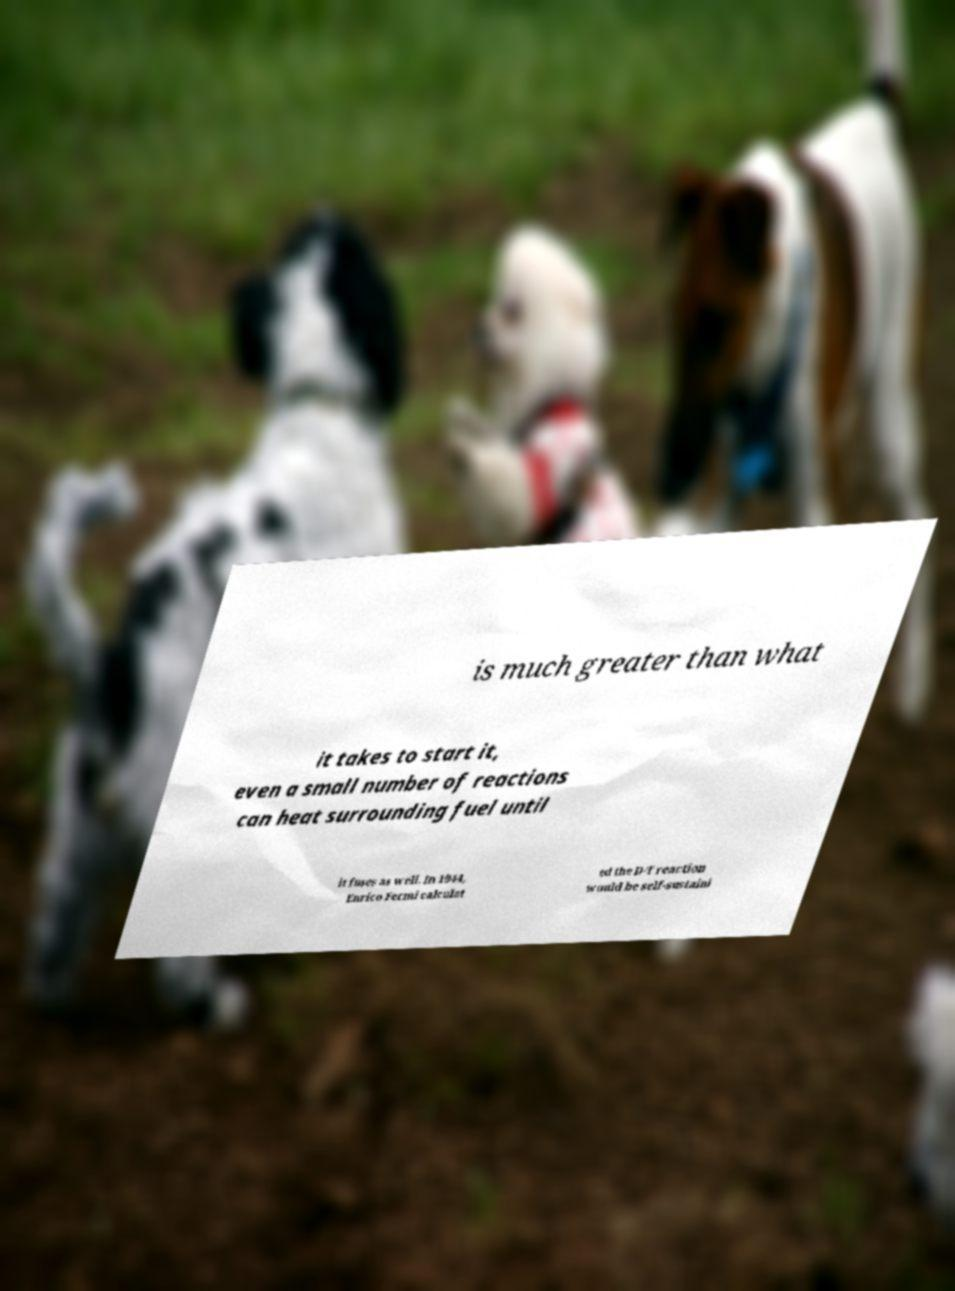For documentation purposes, I need the text within this image transcribed. Could you provide that? is much greater than what it takes to start it, even a small number of reactions can heat surrounding fuel until it fuses as well. In 1944, Enrico Fermi calculat ed the D-T reaction would be self-sustaini 